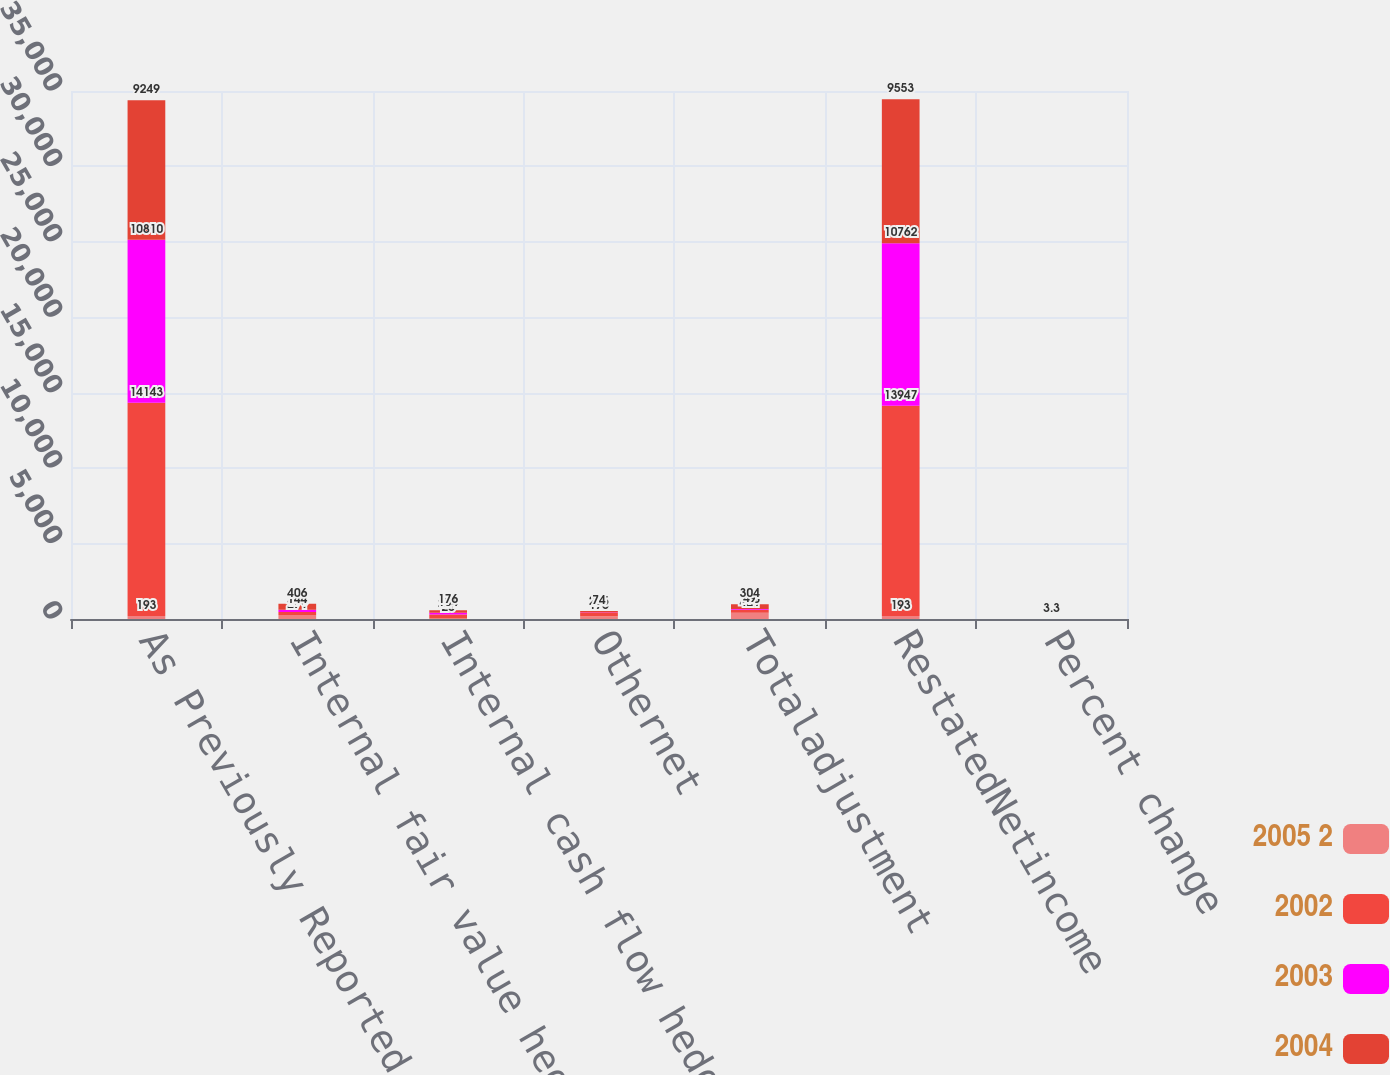Convert chart. <chart><loc_0><loc_0><loc_500><loc_500><stacked_bar_chart><ecel><fcel>As Previously Reported Net<fcel>Internal fair value hedges<fcel>Internal cash flow hedges<fcel>Othernet<fcel>Totaladjustment<fcel>RestatedNetincome<fcel>Percent change<nl><fcel>2005 2<fcel>193<fcel>271<fcel>25<fcel>175<fcel>421<fcel>193<fcel>2.5<nl><fcel>2002<fcel>14143<fcel>190<fcel>281<fcel>275<fcel>196<fcel>13947<fcel>1.4<nl><fcel>2003<fcel>10810<fcel>144<fcel>104<fcel>9<fcel>49<fcel>10762<fcel>0.5<nl><fcel>2004<fcel>9249<fcel>406<fcel>176<fcel>74<fcel>304<fcel>9553<fcel>3.3<nl></chart> 